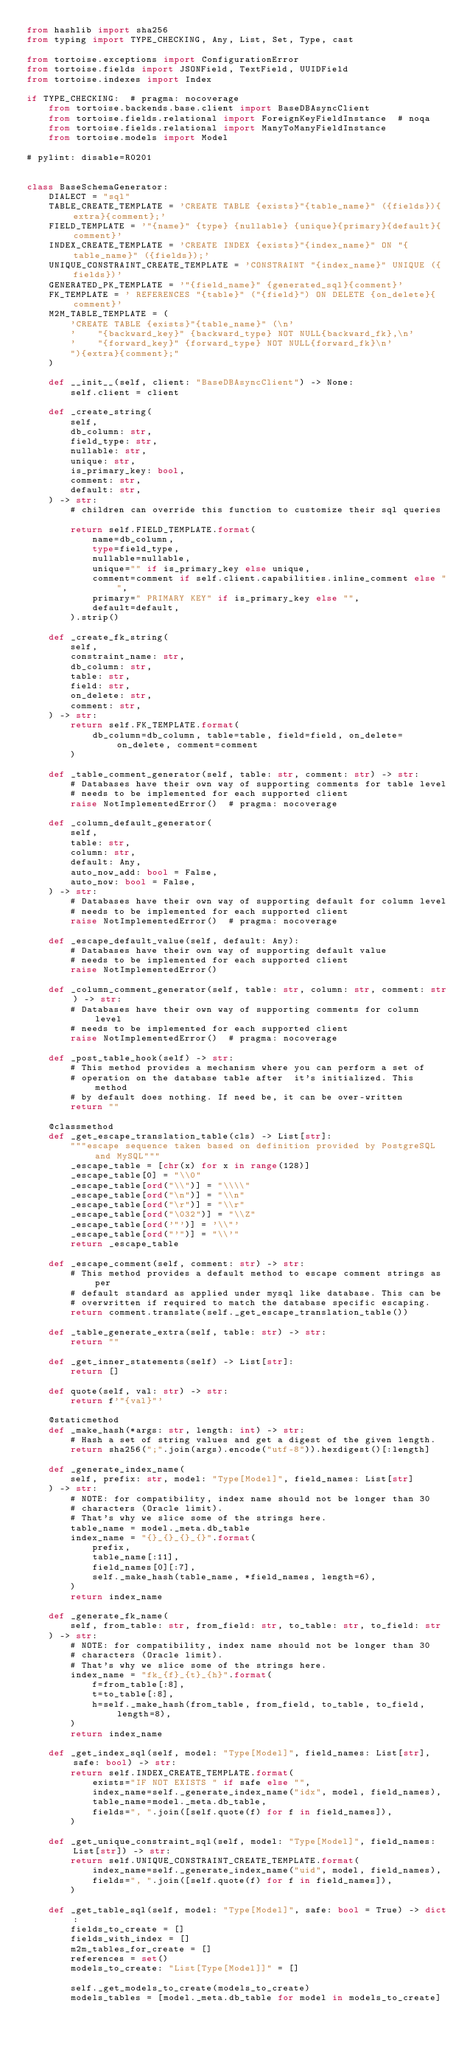<code> <loc_0><loc_0><loc_500><loc_500><_Python_>from hashlib import sha256
from typing import TYPE_CHECKING, Any, List, Set, Type, cast

from tortoise.exceptions import ConfigurationError
from tortoise.fields import JSONField, TextField, UUIDField
from tortoise.indexes import Index

if TYPE_CHECKING:  # pragma: nocoverage
    from tortoise.backends.base.client import BaseDBAsyncClient
    from tortoise.fields.relational import ForeignKeyFieldInstance  # noqa
    from tortoise.fields.relational import ManyToManyFieldInstance
    from tortoise.models import Model

# pylint: disable=R0201


class BaseSchemaGenerator:
    DIALECT = "sql"
    TABLE_CREATE_TEMPLATE = 'CREATE TABLE {exists}"{table_name}" ({fields}){extra}{comment};'
    FIELD_TEMPLATE = '"{name}" {type} {nullable} {unique}{primary}{default}{comment}'
    INDEX_CREATE_TEMPLATE = 'CREATE INDEX {exists}"{index_name}" ON "{table_name}" ({fields});'
    UNIQUE_CONSTRAINT_CREATE_TEMPLATE = 'CONSTRAINT "{index_name}" UNIQUE ({fields})'
    GENERATED_PK_TEMPLATE = '"{field_name}" {generated_sql}{comment}'
    FK_TEMPLATE = ' REFERENCES "{table}" ("{field}") ON DELETE {on_delete}{comment}'
    M2M_TABLE_TEMPLATE = (
        'CREATE TABLE {exists}"{table_name}" (\n'
        '    "{backward_key}" {backward_type} NOT NULL{backward_fk},\n'
        '    "{forward_key}" {forward_type} NOT NULL{forward_fk}\n'
        "){extra}{comment};"
    )

    def __init__(self, client: "BaseDBAsyncClient") -> None:
        self.client = client

    def _create_string(
        self,
        db_column: str,
        field_type: str,
        nullable: str,
        unique: str,
        is_primary_key: bool,
        comment: str,
        default: str,
    ) -> str:
        # children can override this function to customize their sql queries

        return self.FIELD_TEMPLATE.format(
            name=db_column,
            type=field_type,
            nullable=nullable,
            unique="" if is_primary_key else unique,
            comment=comment if self.client.capabilities.inline_comment else "",
            primary=" PRIMARY KEY" if is_primary_key else "",
            default=default,
        ).strip()

    def _create_fk_string(
        self,
        constraint_name: str,
        db_column: str,
        table: str,
        field: str,
        on_delete: str,
        comment: str,
    ) -> str:
        return self.FK_TEMPLATE.format(
            db_column=db_column, table=table, field=field, on_delete=on_delete, comment=comment
        )

    def _table_comment_generator(self, table: str, comment: str) -> str:
        # Databases have their own way of supporting comments for table level
        # needs to be implemented for each supported client
        raise NotImplementedError()  # pragma: nocoverage

    def _column_default_generator(
        self,
        table: str,
        column: str,
        default: Any,
        auto_now_add: bool = False,
        auto_now: bool = False,
    ) -> str:
        # Databases have their own way of supporting default for column level
        # needs to be implemented for each supported client
        raise NotImplementedError()  # pragma: nocoverage

    def _escape_default_value(self, default: Any):
        # Databases have their own way of supporting default value
        # needs to be implemented for each supported client
        raise NotImplementedError()

    def _column_comment_generator(self, table: str, column: str, comment: str) -> str:
        # Databases have their own way of supporting comments for column level
        # needs to be implemented for each supported client
        raise NotImplementedError()  # pragma: nocoverage

    def _post_table_hook(self) -> str:
        # This method provides a mechanism where you can perform a set of
        # operation on the database table after  it's initialized. This method
        # by default does nothing. If need be, it can be over-written
        return ""

    @classmethod
    def _get_escape_translation_table(cls) -> List[str]:
        """escape sequence taken based on definition provided by PostgreSQL and MySQL"""
        _escape_table = [chr(x) for x in range(128)]
        _escape_table[0] = "\\0"
        _escape_table[ord("\\")] = "\\\\"
        _escape_table[ord("\n")] = "\\n"
        _escape_table[ord("\r")] = "\\r"
        _escape_table[ord("\032")] = "\\Z"
        _escape_table[ord('"')] = '\\"'
        _escape_table[ord("'")] = "\\'"
        return _escape_table

    def _escape_comment(self, comment: str) -> str:
        # This method provides a default method to escape comment strings as per
        # default standard as applied under mysql like database. This can be
        # overwritten if required to match the database specific escaping.
        return comment.translate(self._get_escape_translation_table())

    def _table_generate_extra(self, table: str) -> str:
        return ""

    def _get_inner_statements(self) -> List[str]:
        return []

    def quote(self, val: str) -> str:
        return f'"{val}"'

    @staticmethod
    def _make_hash(*args: str, length: int) -> str:
        # Hash a set of string values and get a digest of the given length.
        return sha256(";".join(args).encode("utf-8")).hexdigest()[:length]

    def _generate_index_name(
        self, prefix: str, model: "Type[Model]", field_names: List[str]
    ) -> str:
        # NOTE: for compatibility, index name should not be longer than 30
        # characters (Oracle limit).
        # That's why we slice some of the strings here.
        table_name = model._meta.db_table
        index_name = "{}_{}_{}_{}".format(
            prefix,
            table_name[:11],
            field_names[0][:7],
            self._make_hash(table_name, *field_names, length=6),
        )
        return index_name

    def _generate_fk_name(
        self, from_table: str, from_field: str, to_table: str, to_field: str
    ) -> str:
        # NOTE: for compatibility, index name should not be longer than 30
        # characters (Oracle limit).
        # That's why we slice some of the strings here.
        index_name = "fk_{f}_{t}_{h}".format(
            f=from_table[:8],
            t=to_table[:8],
            h=self._make_hash(from_table, from_field, to_table, to_field, length=8),
        )
        return index_name

    def _get_index_sql(self, model: "Type[Model]", field_names: List[str], safe: bool) -> str:
        return self.INDEX_CREATE_TEMPLATE.format(
            exists="IF NOT EXISTS " if safe else "",
            index_name=self._generate_index_name("idx", model, field_names),
            table_name=model._meta.db_table,
            fields=", ".join([self.quote(f) for f in field_names]),
        )

    def _get_unique_constraint_sql(self, model: "Type[Model]", field_names: List[str]) -> str:
        return self.UNIQUE_CONSTRAINT_CREATE_TEMPLATE.format(
            index_name=self._generate_index_name("uid", model, field_names),
            fields=", ".join([self.quote(f) for f in field_names]),
        )

    def _get_table_sql(self, model: "Type[Model]", safe: bool = True) -> dict:
        fields_to_create = []
        fields_with_index = []
        m2m_tables_for_create = []
        references = set()
        models_to_create: "List[Type[Model]]" = []

        self._get_models_to_create(models_to_create)
        models_tables = [model._meta.db_table for model in models_to_create]</code> 